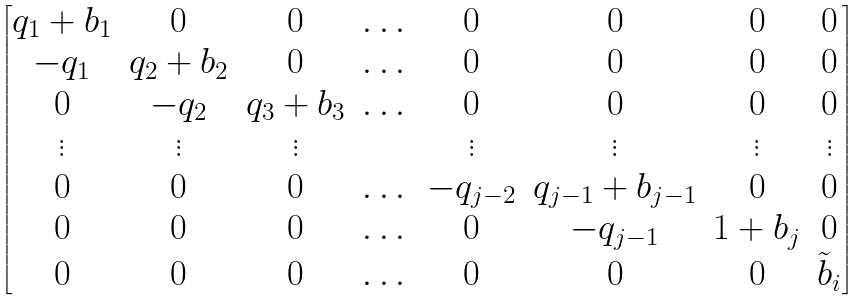Convert formula to latex. <formula><loc_0><loc_0><loc_500><loc_500>\begin{bmatrix} q _ { 1 } + b _ { 1 } & 0 & 0 & \dots & 0 & 0 & 0 & 0 \\ - q _ { 1 } & q _ { 2 } + b _ { 2 } & 0 & \dots & 0 & 0 & 0 & 0 \\ 0 & - q _ { 2 } & q _ { 3 } + b _ { 3 } & \dots & 0 & 0 & 0 & 0 \\ \vdots & \vdots & \vdots & & \vdots & \vdots & \vdots & \vdots \\ 0 & 0 & 0 & \dots & - q _ { j - 2 } & q _ { j - 1 } + b _ { j - 1 } & 0 & 0 \\ 0 & 0 & 0 & \dots & 0 & - q _ { j - 1 } & 1 + b _ { j } & 0 \\ 0 & 0 & 0 & \dots & 0 & 0 & 0 & \tilde { b } _ { i } \end{bmatrix}</formula> 